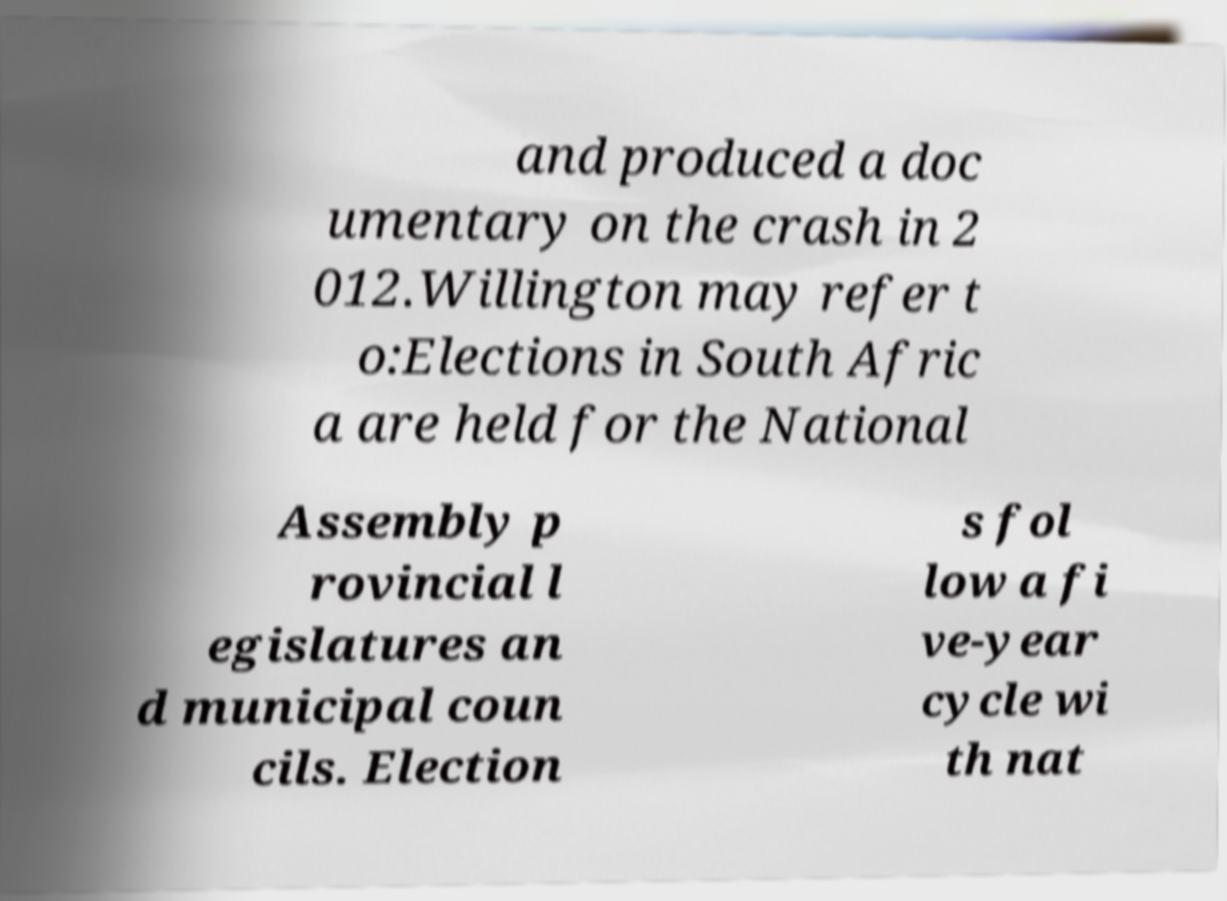I need the written content from this picture converted into text. Can you do that? and produced a doc umentary on the crash in 2 012.Willington may refer t o:Elections in South Afric a are held for the National Assembly p rovincial l egislatures an d municipal coun cils. Election s fol low a fi ve-year cycle wi th nat 